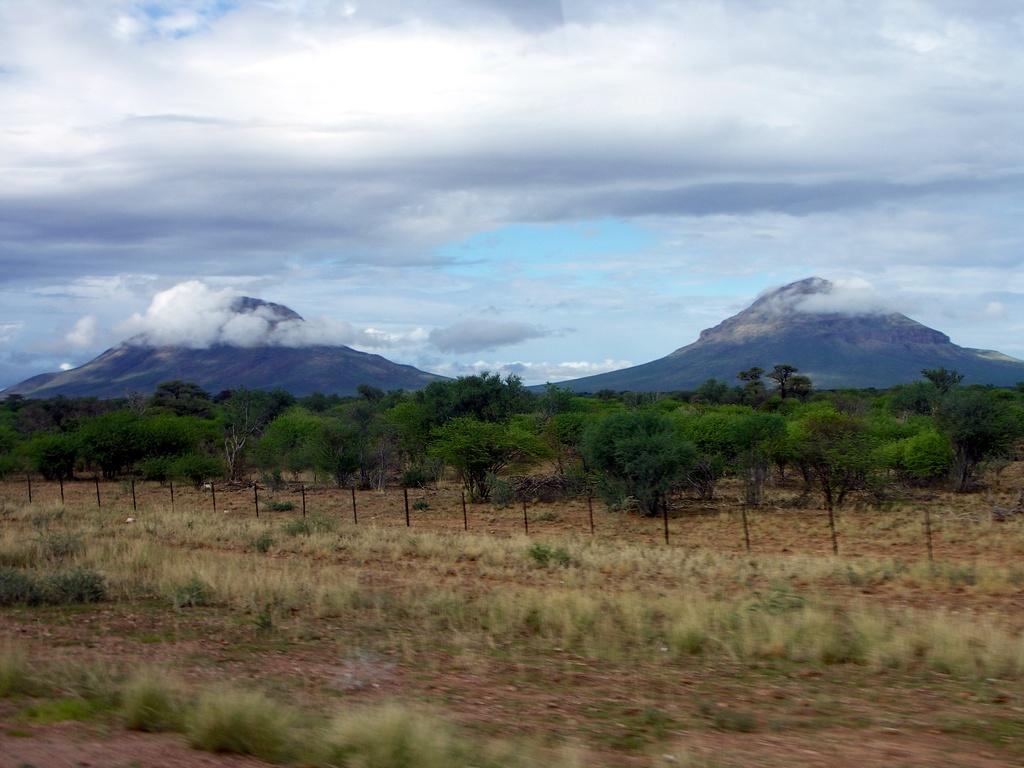What type of vegetation can be seen in the image? There are trees and plants visible in the image. What geographical feature is present in the image? There are mountains in the image. What is visible at the top of the image? The sky is visible at the top of the image. What can be seen in the sky? There are clouds in the sky. What is present at the bottom of the image? There are plants and mud at the bottom of the image. What type of nose can be seen on the mountain in the image? There is no nose present on the mountain in the image. Is there a locket hanging from one of the trees in the image? There is no locket present on any of the trees in the image. 